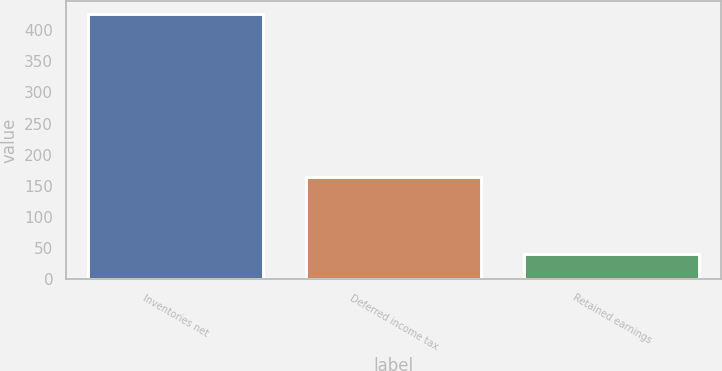Convert chart. <chart><loc_0><loc_0><loc_500><loc_500><bar_chart><fcel>Inventories net<fcel>Deferred income tax<fcel>Retained earnings<nl><fcel>426<fcel>165<fcel>40<nl></chart> 